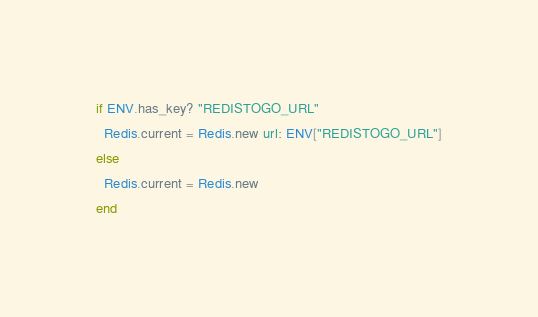<code> <loc_0><loc_0><loc_500><loc_500><_Ruby_>if ENV.has_key? "REDISTOGO_URL"
  Redis.current = Redis.new url: ENV["REDISTOGO_URL"]
else
  Redis.current = Redis.new
end
</code> 